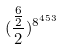Convert formula to latex. <formula><loc_0><loc_0><loc_500><loc_500>( \frac { \frac { 6 } { 2 } } { 2 } ) ^ { 8 ^ { 4 5 3 } }</formula> 